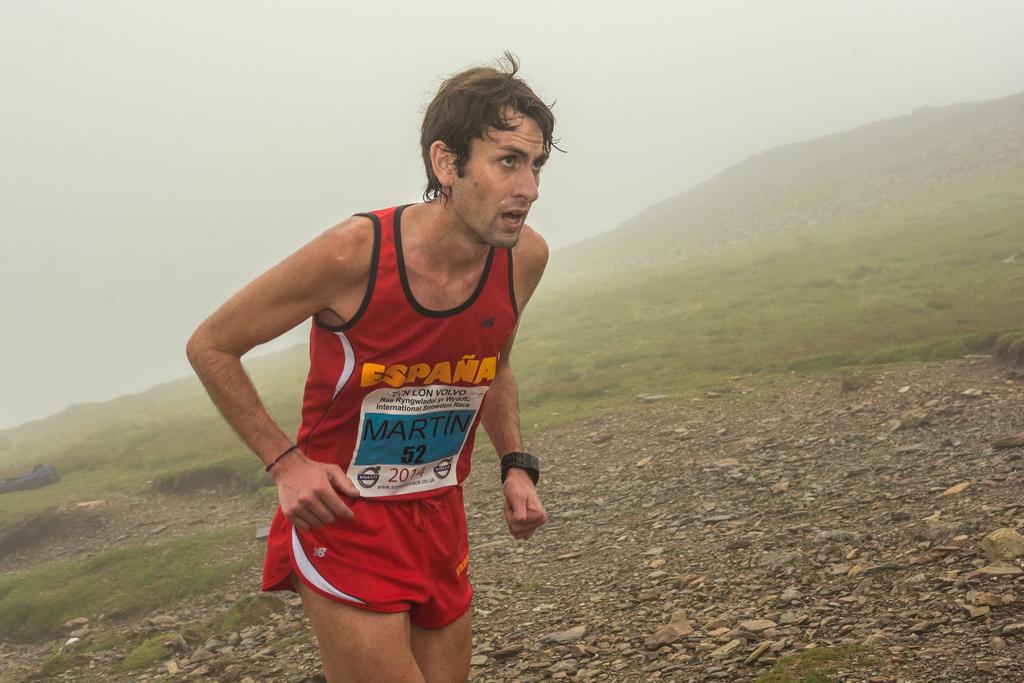<image>
Share a concise interpretation of the image provided. a man running while wearing an Espana shirt 